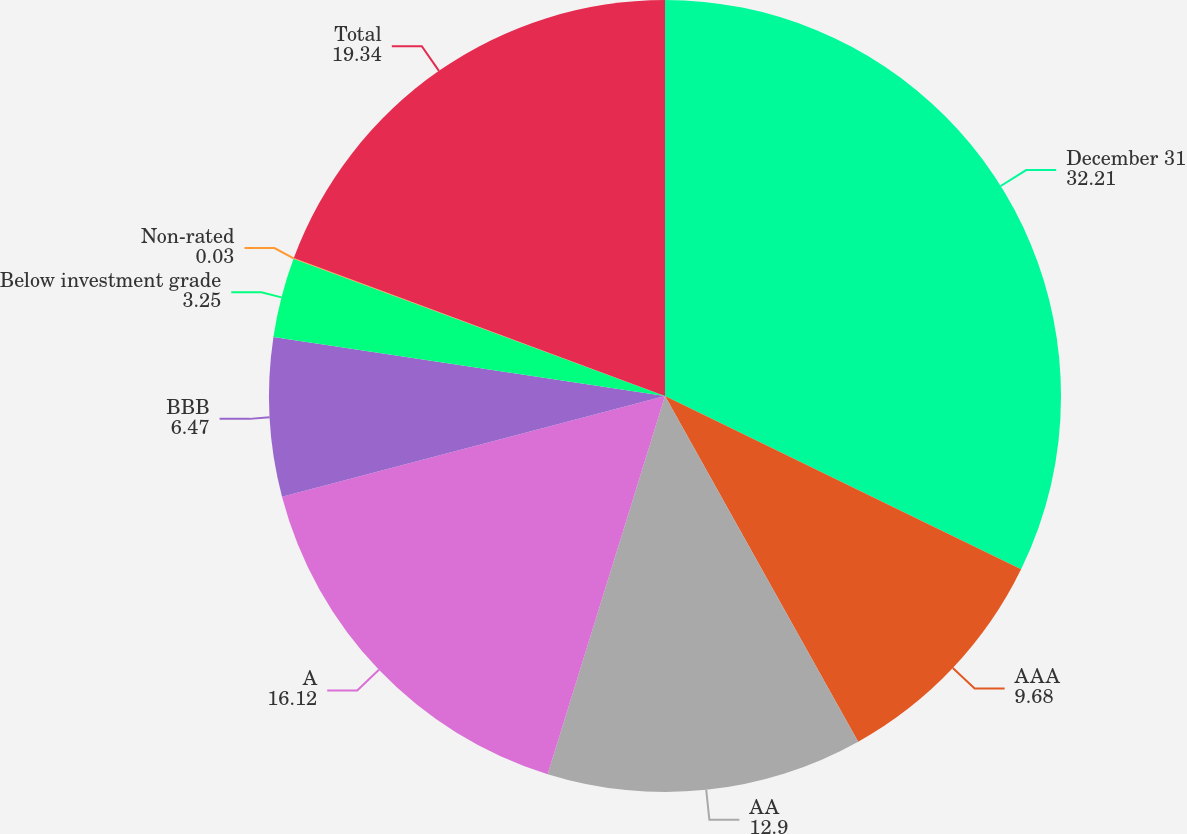<chart> <loc_0><loc_0><loc_500><loc_500><pie_chart><fcel>December 31<fcel>AAA<fcel>AA<fcel>A<fcel>BBB<fcel>Below investment grade<fcel>Non-rated<fcel>Total<nl><fcel>32.21%<fcel>9.68%<fcel>12.9%<fcel>16.12%<fcel>6.47%<fcel>3.25%<fcel>0.03%<fcel>19.34%<nl></chart> 